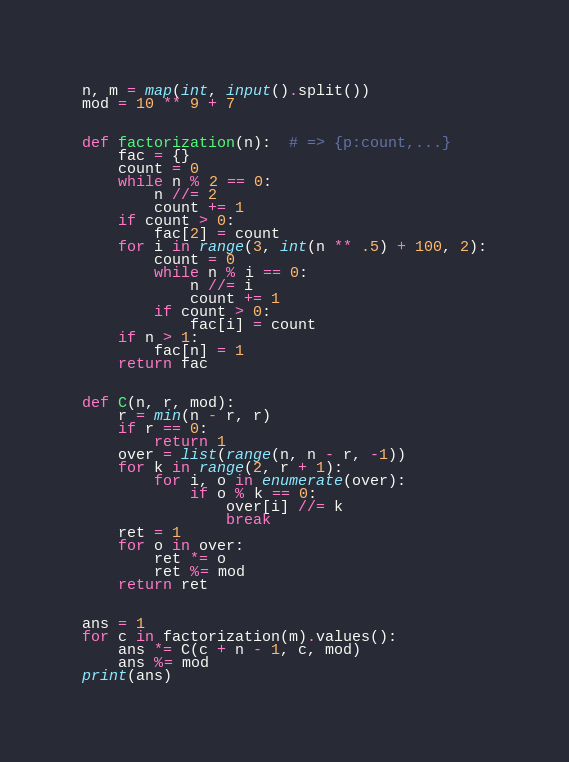Convert code to text. <code><loc_0><loc_0><loc_500><loc_500><_Python_>n, m = map(int, input().split())
mod = 10 ** 9 + 7


def factorization(n):  # => {p:count,...}
    fac = {}
    count = 0
    while n % 2 == 0:
        n //= 2
        count += 1
    if count > 0:
        fac[2] = count
    for i in range(3, int(n ** .5) + 100, 2):
        count = 0
        while n % i == 0:
            n //= i
            count += 1
        if count > 0:
            fac[i] = count
    if n > 1:
        fac[n] = 1
    return fac


def C(n, r, mod):
    r = min(n - r, r)
    if r == 0:
        return 1
    over = list(range(n, n - r, -1))
    for k in range(2, r + 1):
        for i, o in enumerate(over):
            if o % k == 0:
                over[i] //= k
                break
    ret = 1
    for o in over:
        ret *= o
        ret %= mod
    return ret


ans = 1
for c in factorization(m).values():
    ans *= C(c + n - 1, c, mod)
    ans %= mod
print(ans)</code> 